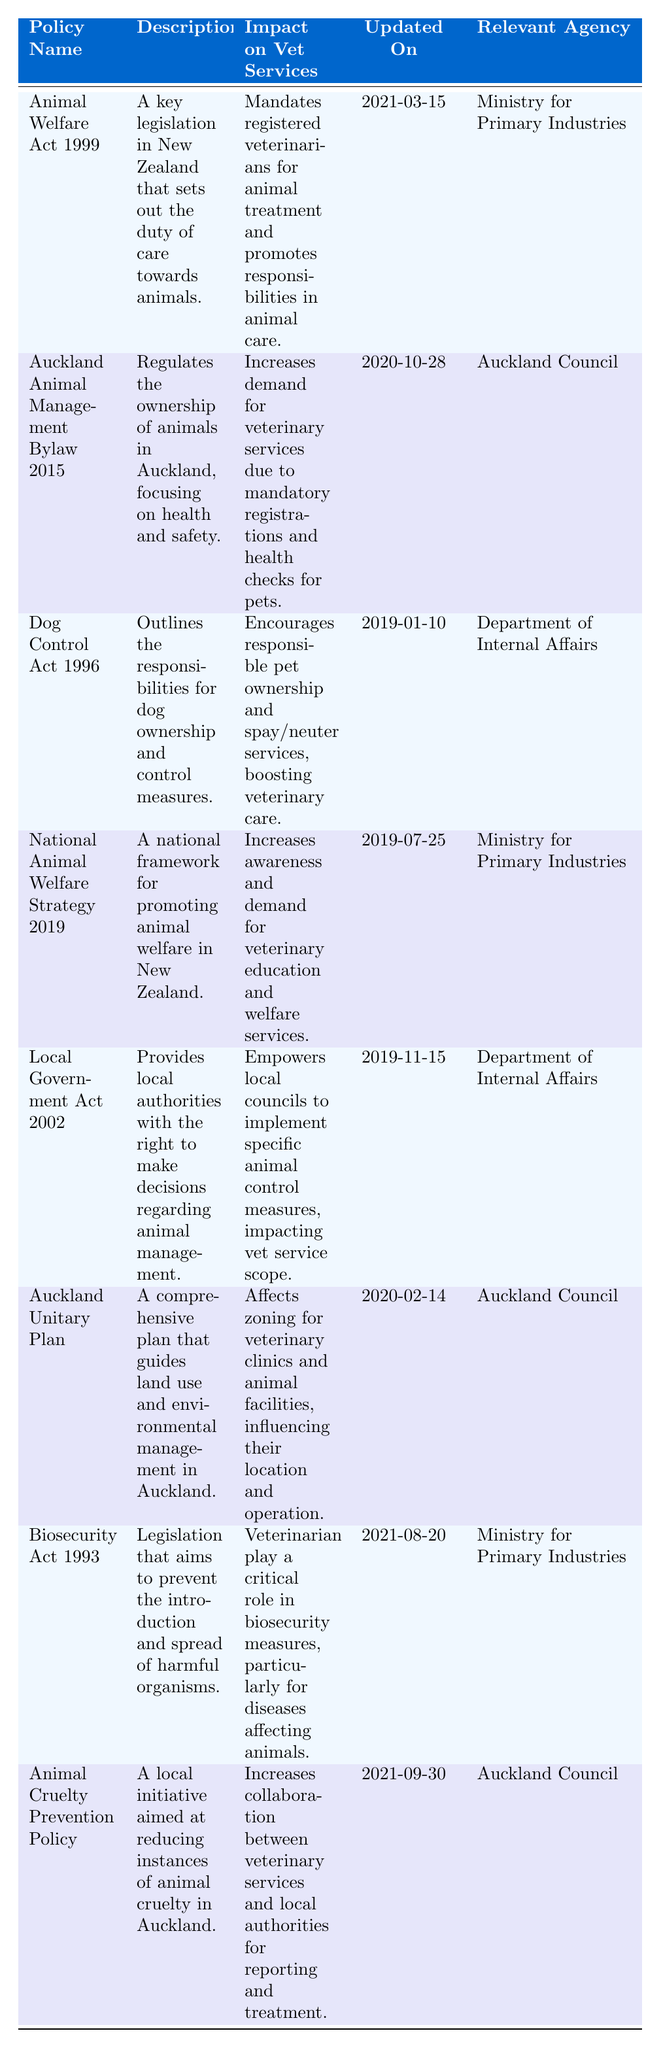What is the most recent policy updated in the table? The most recent policy based on the "Updated On" column is the "Animal Cruelty Prevention Policy," which was updated on 2021-09-30.
Answer: Animal Cruelty Prevention Policy Which agency is responsible for the Animal Welfare Act 1999? The "Relevant Agency" column indicates that the Ministry for Primary Industries is responsible for the Animal Welfare Act 1999.
Answer: Ministry for Primary Industries Does the Auckland Animal Management Bylaw 2015 increase the demand for veterinary services? The impact specified in the table states that it increases demand for veterinary services due to mandatory registrations and health checks for pets, confirming that the statement is true.
Answer: Yes How many policies are updated after 2019? Examining the "Updated On" dates, the policies updated after 2019 are "Animal Welfare Act 1999," "Auckland Animal Management Bylaw 2015," "Biosecurity Act 1993," and "Animal Cruelty Prevention Policy," totaling to four.
Answer: 4 What is the impact of the Local Government Act 2002 on veterinary services? The impact stated in the table is that it empowers local councils to implement specific animal control measures, which directly affects the scope of veterinary services provided in Auckland.
Answer: Empowers local councils How many policies are relevant to the Auckland Council? The relevant agencies for the policies are "Auckland Council" for the Auckland Animal Management Bylaw 2015, the Auckland Unitary Plan, and the Animal Cruelty Prevention Policy. This gives us a total of three policies relevant to the Auckland Council.
Answer: 3 Does the National Animal Welfare Strategy 2019 focus on animal education? The impact on veterinary services mentions that it increases awareness and demand for veterinary education and welfare services, affirming the focus on animal education is indeed included.
Answer: Yes Which policy affects zoning for veterinary clinics? The "Auckland Unitary Plan" details the impact on zoning for veterinary clinics and animal facilities, thus it affects the location and operation of these services.
Answer: Auckland Unitary Plan 